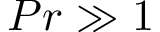<formula> <loc_0><loc_0><loc_500><loc_500>P r \gg 1</formula> 